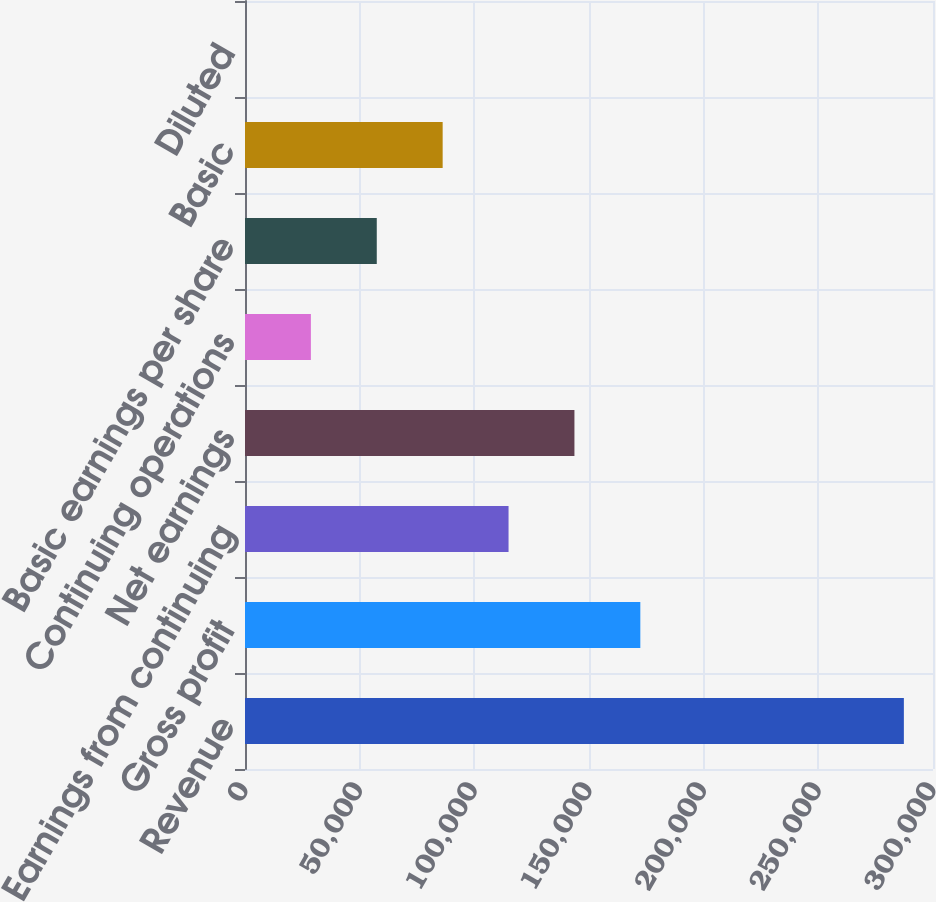Convert chart. <chart><loc_0><loc_0><loc_500><loc_500><bar_chart><fcel>Revenue<fcel>Gross profit<fcel>Earnings from continuing<fcel>Net earnings<fcel>Continuing operations<fcel>Basic earnings per share<fcel>Basic<fcel>Diluted<nl><fcel>287298<fcel>172379<fcel>114919<fcel>143649<fcel>28730.1<fcel>57459.9<fcel>86189.6<fcel>0.35<nl></chart> 